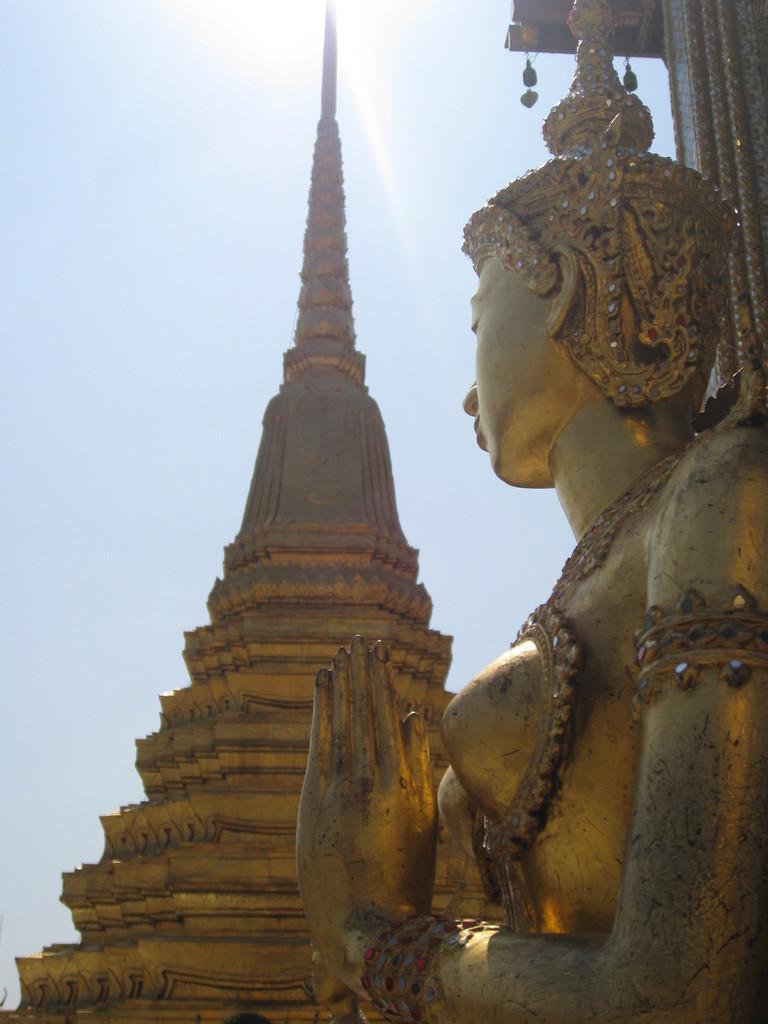In one or two sentences, can you explain what this image depicts? In this picture there is a building and there is a sculpture. At the top there is sky and there is sun. 